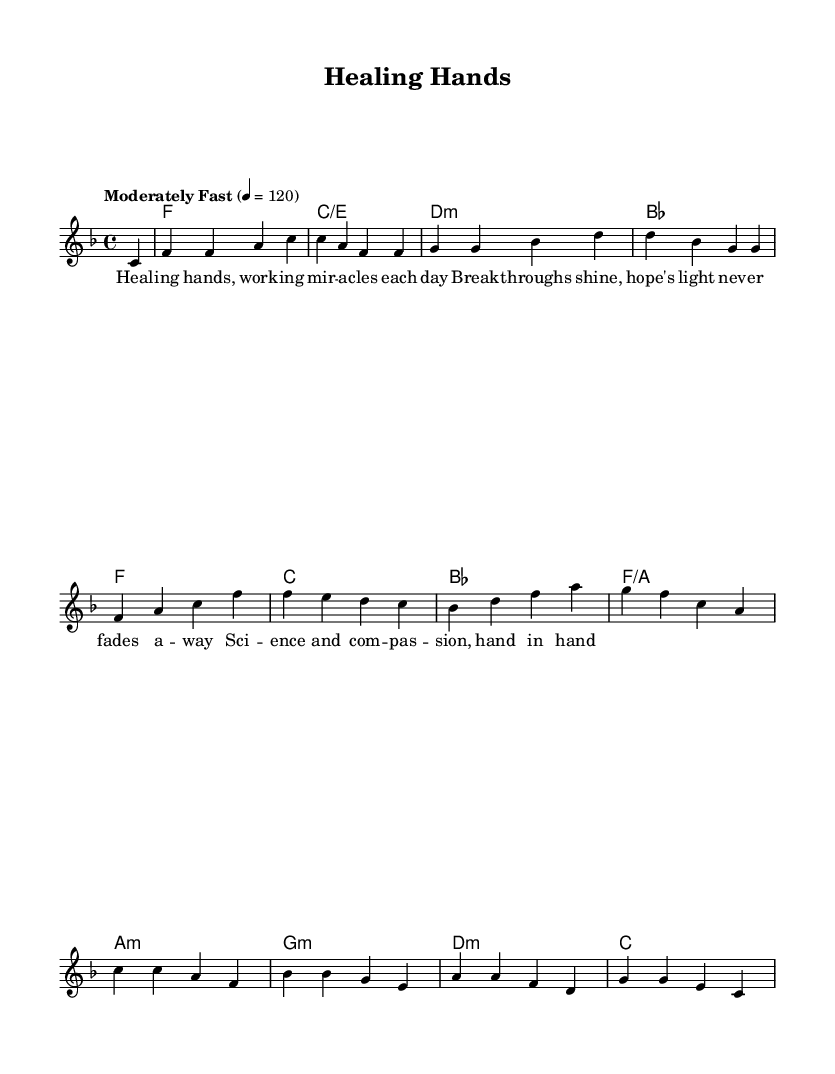What is the key signature of this music? The key signature is F major, which contains one flat (B flat). This can be determined by identifying the key signature indicated in the score.
Answer: F major What is the time signature of this music? The time signature is 4/4, which is evident from the notation shown at the beginning of the score. 4/4 indicates that there are four beats per measure, and each beat is a quarter note.
Answer: 4/4 What is the tempo marking of this piece? The tempo marking is "Moderately Fast" with a metronome marking of 120 beats per minute. This is explicitly stated in the score under the tempo text.
Answer: Moderately Fast How many measures are there in the piece? There are 8 measures in the score, which can be counted from the beginning to the end of the provided melody line.
Answer: 8 measures What is the first lyric line of the song? The first lyric line is "Healing hands, working miracles each day." This is derived from the lyrics aligned with the melody in the score.
Answer: Healing hands, working miracles each day Which two contrasting elements does the song highlight? The song highlights "science and compassion," as stated in the lyrics. This reflects the dual nature of medical breakthroughs combined with emotional support.
Answer: Science and compassion 